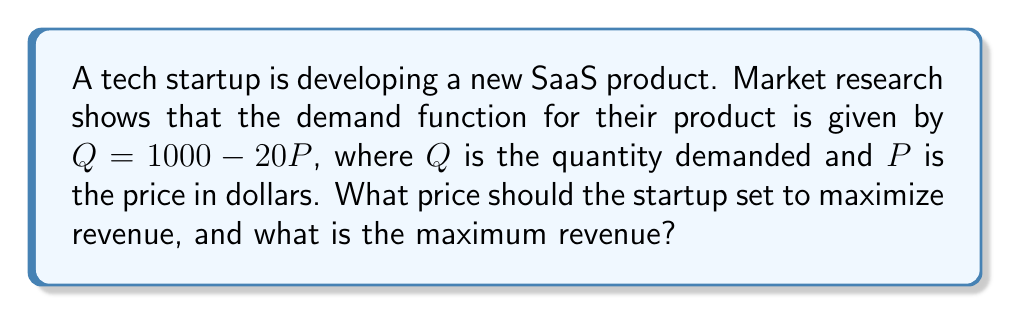Could you help me with this problem? To solve this problem, we'll follow these steps:

1) Revenue (R) is given by the product of price (P) and quantity (Q):
   $R = P \cdot Q$

2) Substitute the demand function into the revenue equation:
   $R = P \cdot (1000 - 20P) = 1000P - 20P^2$

3) To find the maximum revenue, we need to find the price where the derivative of R with respect to P is zero:
   $$\frac{dR}{dP} = 1000 - 40P$$

4) Set this equal to zero and solve for P:
   $$1000 - 40P = 0$$
   $$40P = 1000$$
   $$P = 25$$

5) To confirm this is a maximum (not a minimum), check the second derivative:
   $$\frac{d^2R}{dP^2} = -40$$
   This is negative, confirming we've found a maximum.

6) Calculate the optimal quantity by substituting P = 25 into the demand function:
   $Q = 1000 - 20(25) = 500$

7) Calculate the maximum revenue:
   $R = 25 \cdot 500 = 12,500$

Therefore, the optimal price is $25, and the maximum revenue is $12,500.
Answer: Optimal price: $25; Maximum revenue: $12,500 